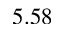Convert formula to latex. <formula><loc_0><loc_0><loc_500><loc_500>5 . 5 8</formula> 